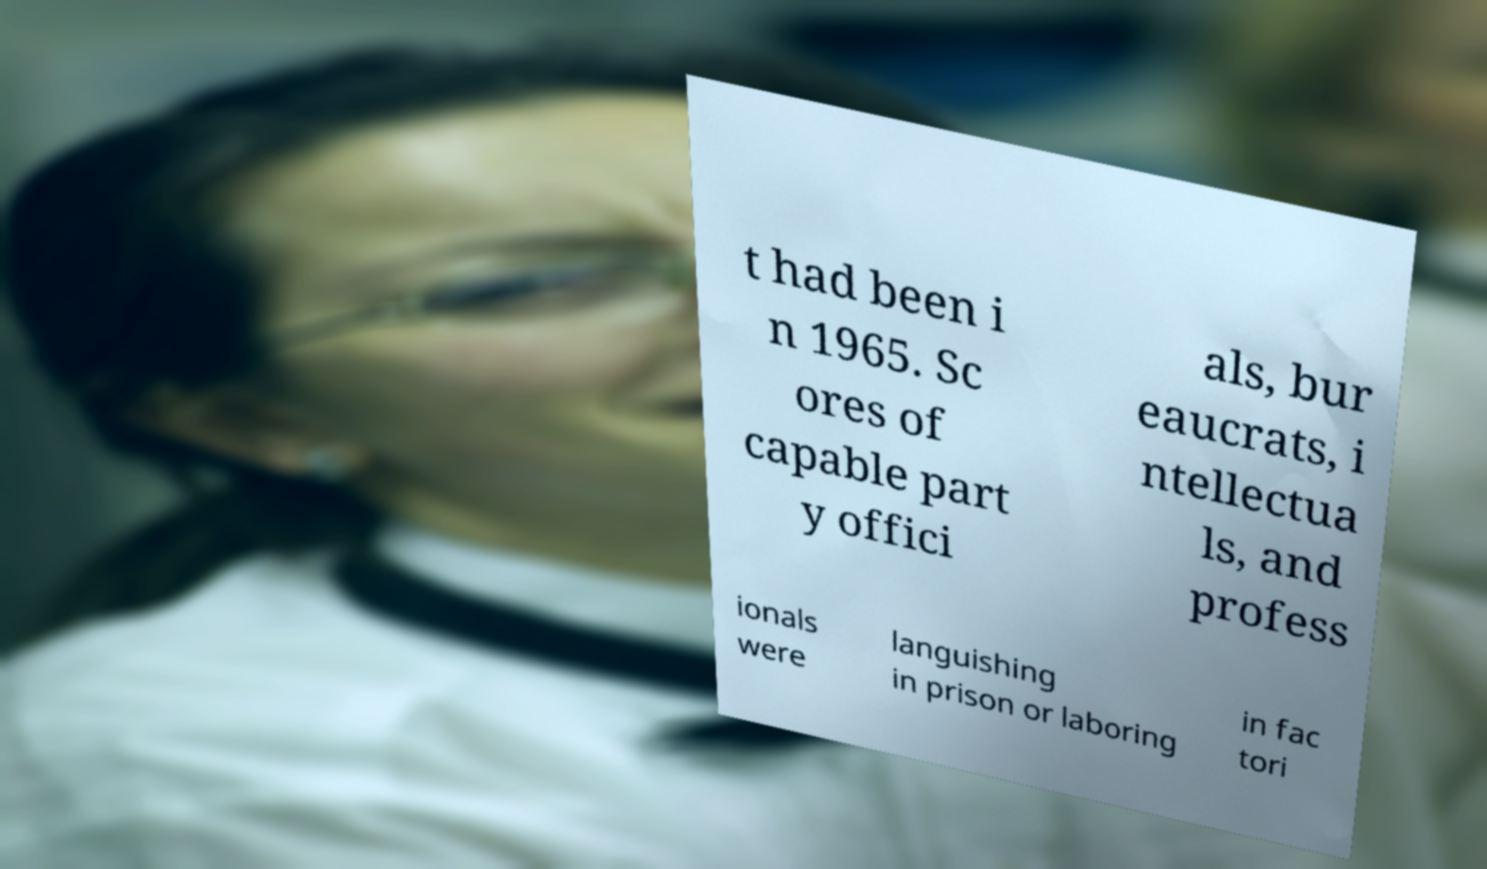Could you extract and type out the text from this image? t had been i n 1965. Sc ores of capable part y offici als, bur eaucrats, i ntellectua ls, and profess ionals were languishing in prison or laboring in fac tori 